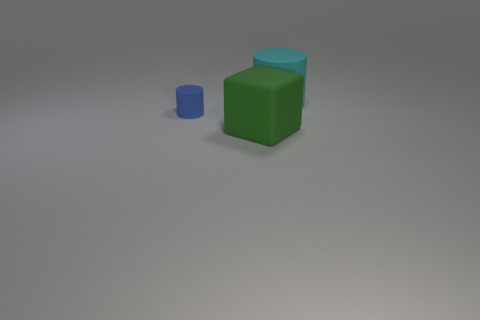Add 2 tiny matte objects. How many objects exist? 5 Subtract all blocks. How many objects are left? 2 Subtract 0 green cylinders. How many objects are left? 3 Subtract all tiny brown rubber things. Subtract all big objects. How many objects are left? 1 Add 1 matte things. How many matte things are left? 4 Add 1 large cubes. How many large cubes exist? 2 